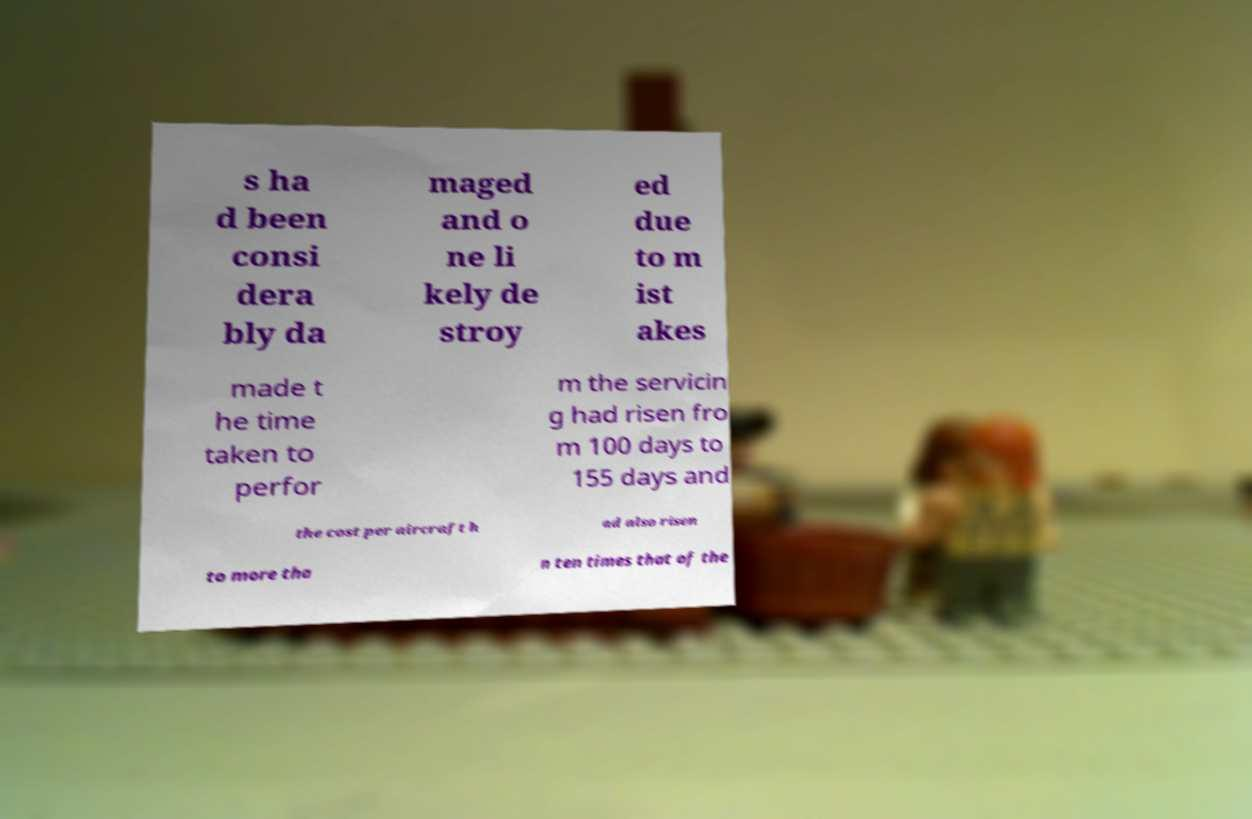Can you read and provide the text displayed in the image?This photo seems to have some interesting text. Can you extract and type it out for me? s ha d been consi dera bly da maged and o ne li kely de stroy ed due to m ist akes made t he time taken to perfor m the servicin g had risen fro m 100 days to 155 days and the cost per aircraft h ad also risen to more tha n ten times that of the 